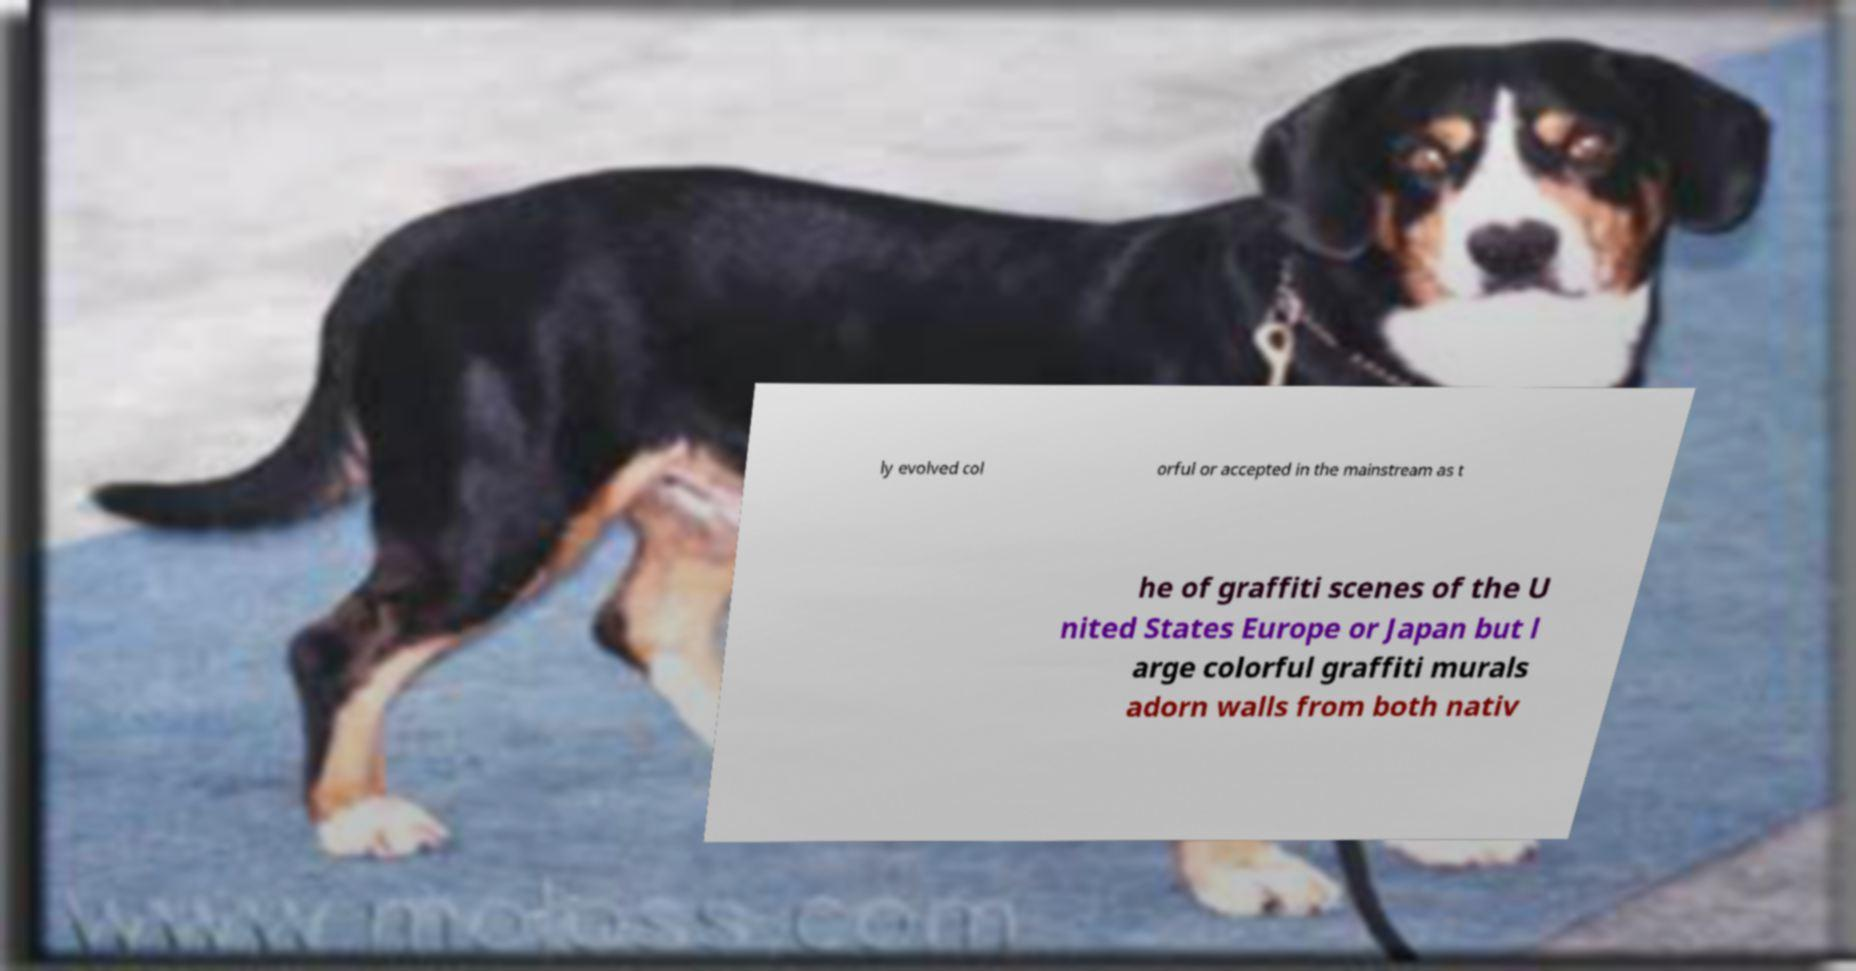Can you accurately transcribe the text from the provided image for me? ly evolved col orful or accepted in the mainstream as t he of graffiti scenes of the U nited States Europe or Japan but l arge colorful graffiti murals adorn walls from both nativ 